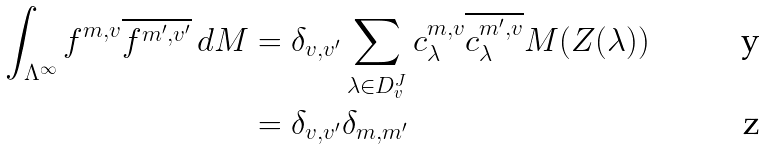Convert formula to latex. <formula><loc_0><loc_0><loc_500><loc_500>\int _ { \Lambda ^ { \infty } } f ^ { m , v } \overline { f ^ { m ^ { \prime } , v ^ { \prime } } } \, d M & = \delta _ { v , v ^ { \prime } } \sum _ { \lambda \in D _ { v } ^ { J } } c ^ { m , v } _ { \lambda } \overline { c ^ { m ^ { \prime } , v } _ { \lambda } } M ( Z ( \lambda ) ) \\ & = \delta _ { v , v ^ { \prime } } \delta _ { m , m ^ { \prime } }</formula> 